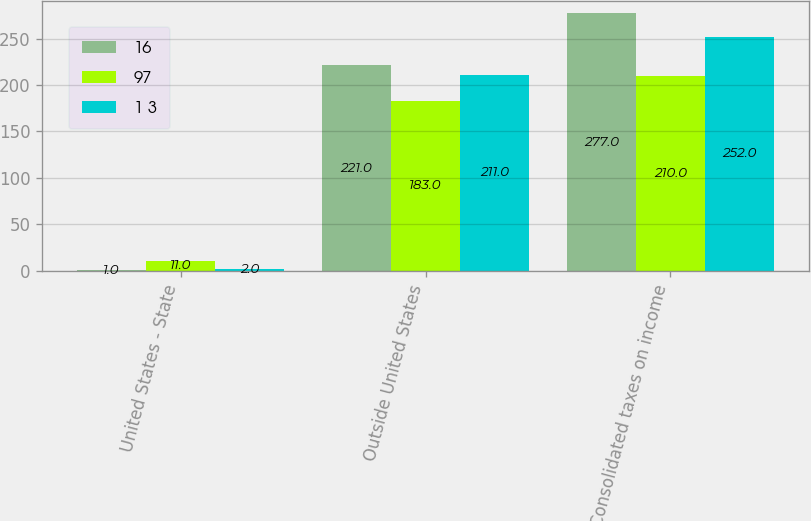Convert chart to OTSL. <chart><loc_0><loc_0><loc_500><loc_500><stacked_bar_chart><ecel><fcel>United States - State<fcel>Outside United States<fcel>Consolidated taxes on income<nl><fcel>16<fcel>1<fcel>221<fcel>277<nl><fcel>97<fcel>11<fcel>183<fcel>210<nl><fcel>1 3<fcel>2<fcel>211<fcel>252<nl></chart> 